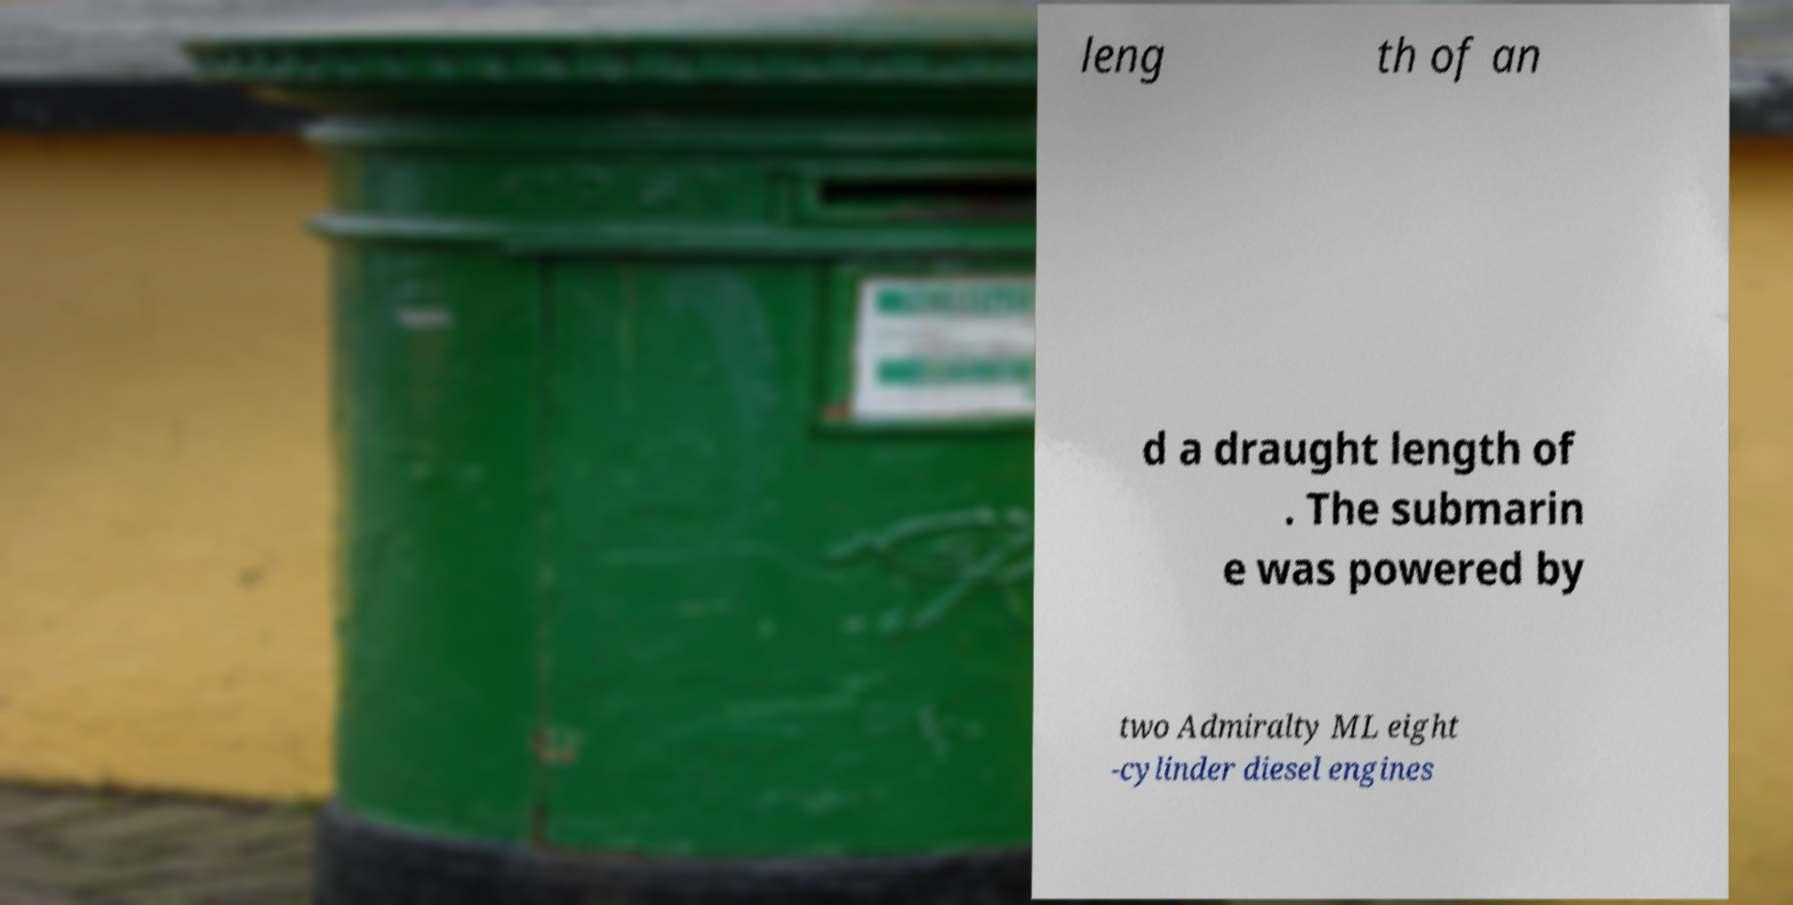Can you accurately transcribe the text from the provided image for me? leng th of an d a draught length of . The submarin e was powered by two Admiralty ML eight -cylinder diesel engines 